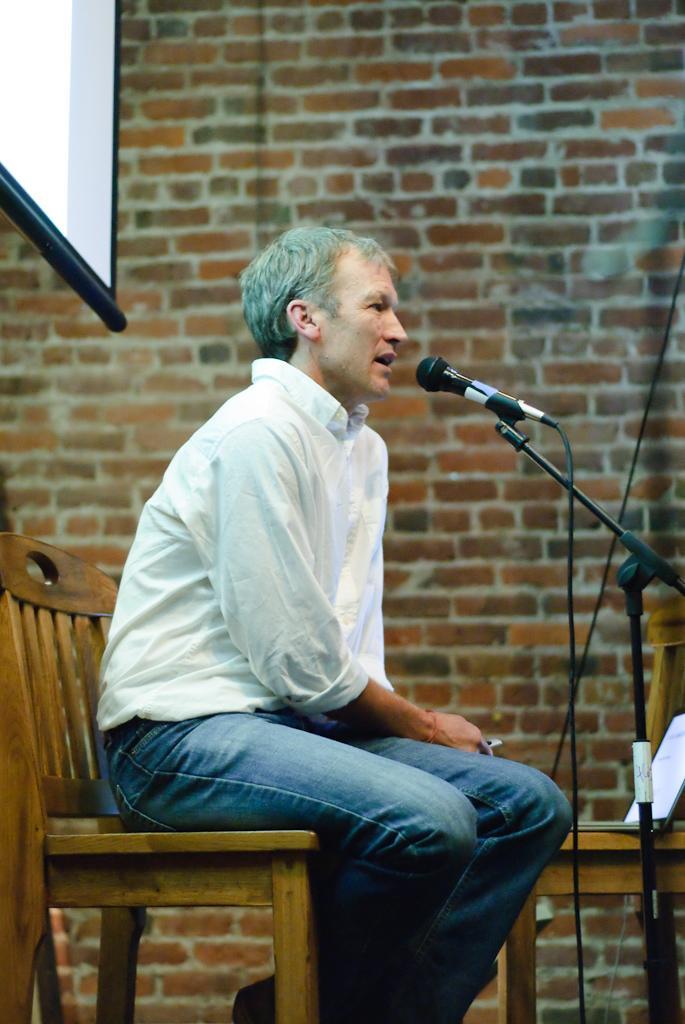Could you give a brief overview of what you see in this image? In this image there is a man sitting in chair , and talking in microphone and in back ground there is screen , book, wall. 